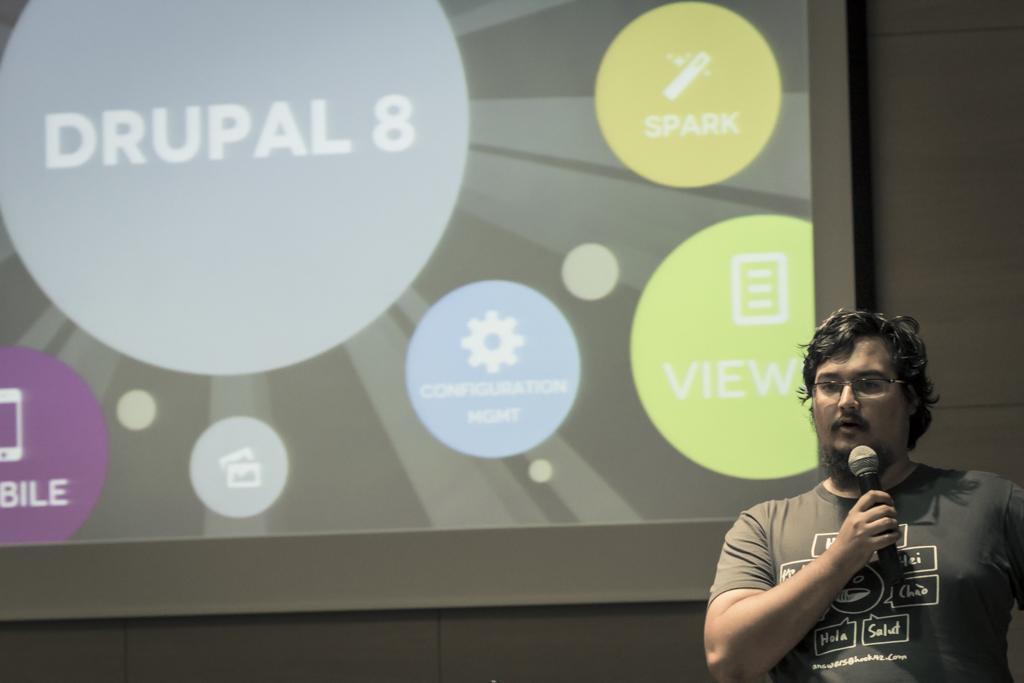Can you describe this image briefly? At the right side of the image, we can see a person is holding a microphone and wearing glasses. Background we can see a screen and wall. 